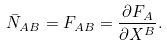Convert formula to latex. <formula><loc_0><loc_0><loc_500><loc_500>\bar { N } _ { A B } = F _ { A B } = \frac { \partial F _ { A } } { \partial X ^ { B } } .</formula> 